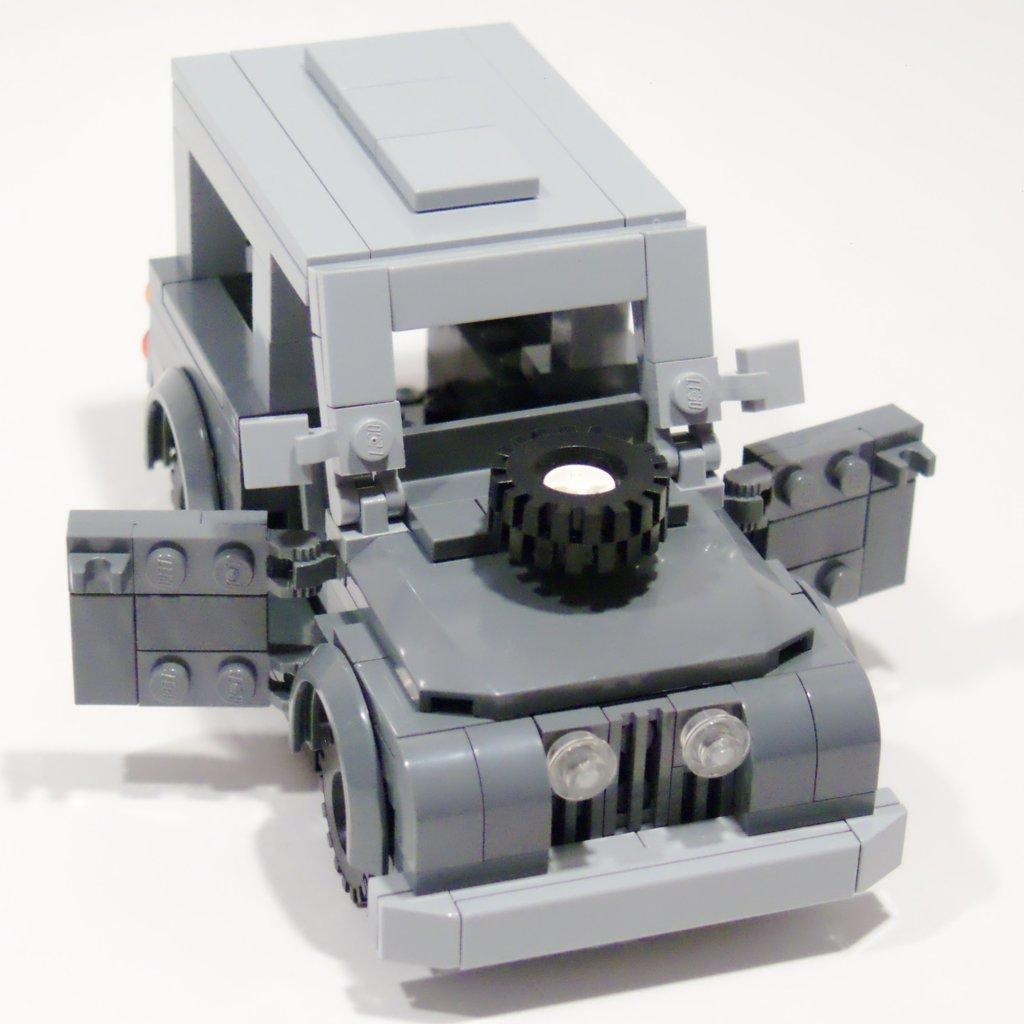What type of toy is in the image? There is a lego toy in the image. What is the lego toy placed on? The lego toy is on an object. What color is the background of the image? The background of the image is white. Can you see a guide for the lego toy in the image? There is no guide for the lego toy visible in the image. Is there a goat in the image? There is no goat present in the image. 